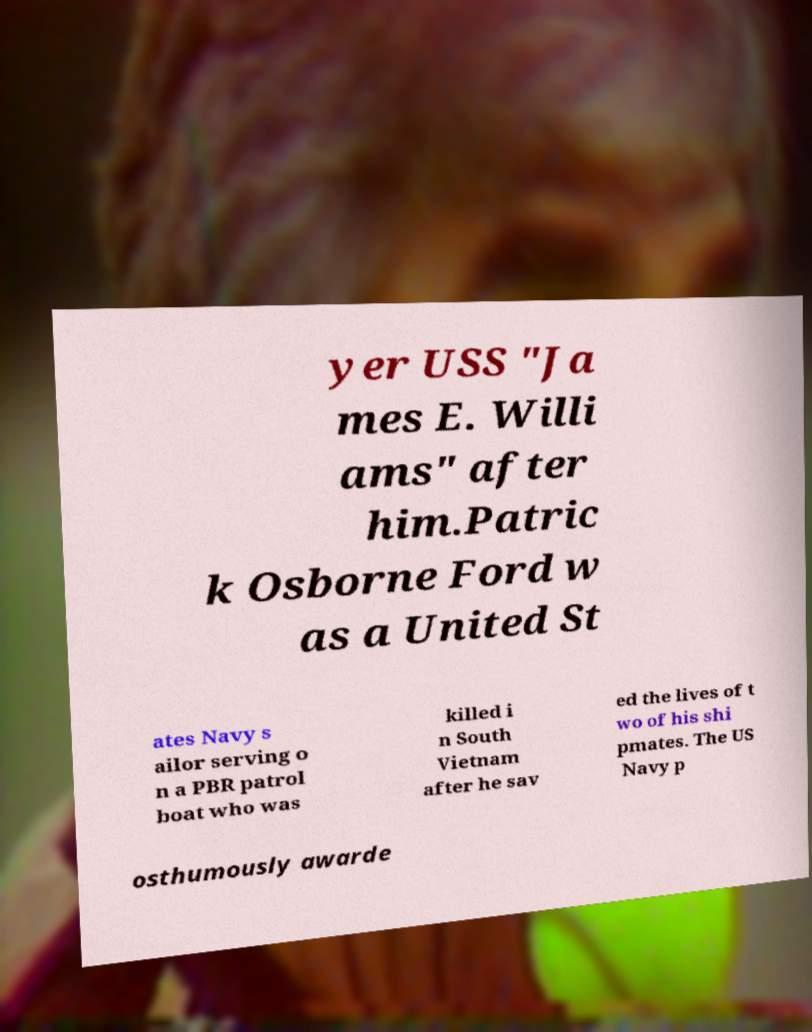For documentation purposes, I need the text within this image transcribed. Could you provide that? yer USS "Ja mes E. Willi ams" after him.Patric k Osborne Ford w as a United St ates Navy s ailor serving o n a PBR patrol boat who was killed i n South Vietnam after he sav ed the lives of t wo of his shi pmates. The US Navy p osthumously awarde 